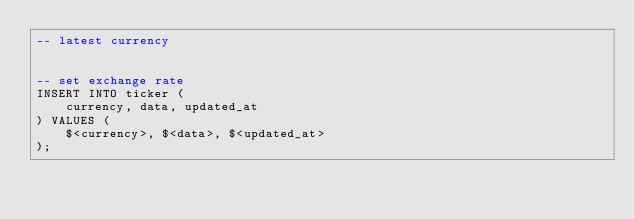Convert code to text. <code><loc_0><loc_0><loc_500><loc_500><_SQL_>-- latest currency


-- set exchange rate
INSERT INTO ticker (
    currency, data, updated_at
) VALUES (
    $<currency>, $<data>, $<updated_at>
);
</code> 